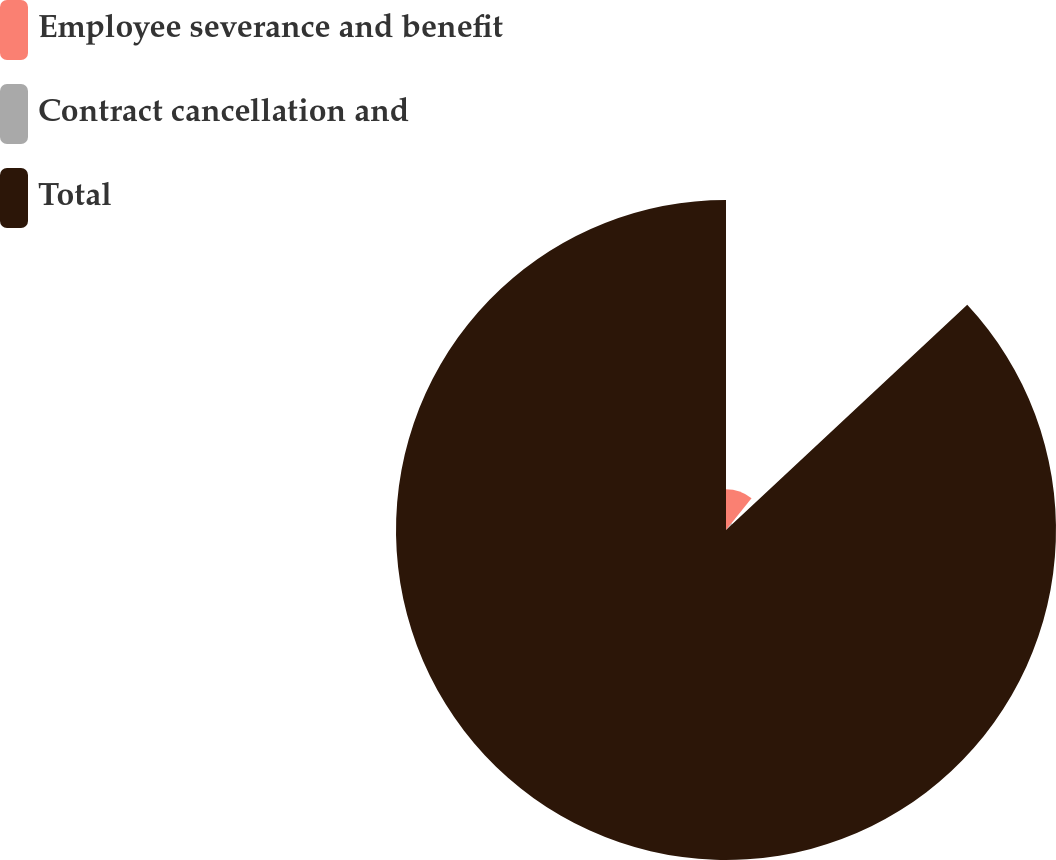Convert chart to OTSL. <chart><loc_0><loc_0><loc_500><loc_500><pie_chart><fcel>Employee severance and benefit<fcel>Contract cancellation and<fcel>Total<nl><fcel>10.76%<fcel>2.29%<fcel>86.96%<nl></chart> 